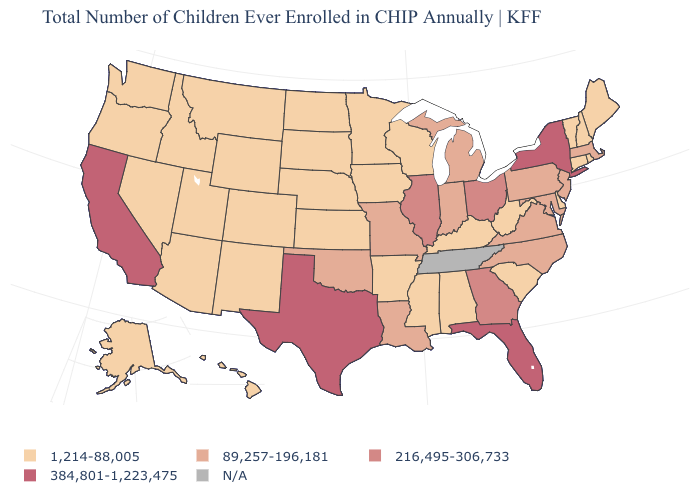How many symbols are there in the legend?
Give a very brief answer. 5. What is the highest value in the South ?
Short answer required. 384,801-1,223,475. What is the value of North Dakota?
Concise answer only. 1,214-88,005. What is the value of New Jersey?
Short answer required. 89,257-196,181. Among the states that border South Carolina , does Georgia have the lowest value?
Write a very short answer. No. What is the value of Washington?
Give a very brief answer. 1,214-88,005. Does West Virginia have the highest value in the USA?
Give a very brief answer. No. Which states have the lowest value in the West?
Write a very short answer. Alaska, Arizona, Colorado, Hawaii, Idaho, Montana, Nevada, New Mexico, Oregon, Utah, Washington, Wyoming. Does Rhode Island have the highest value in the Northeast?
Write a very short answer. No. What is the lowest value in the USA?
Quick response, please. 1,214-88,005. What is the lowest value in the USA?
Be succinct. 1,214-88,005. Does Montana have the highest value in the West?
Keep it brief. No. Does Massachusetts have the highest value in the Northeast?
Answer briefly. No. 